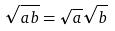<formula> <loc_0><loc_0><loc_500><loc_500>\sqrt { a b } = \sqrt { a } \sqrt { b }</formula> 